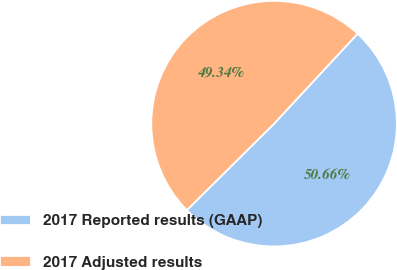Convert chart to OTSL. <chart><loc_0><loc_0><loc_500><loc_500><pie_chart><fcel>2017 Reported results (GAAP)<fcel>2017 Adjusted results<nl><fcel>50.66%<fcel>49.34%<nl></chart> 